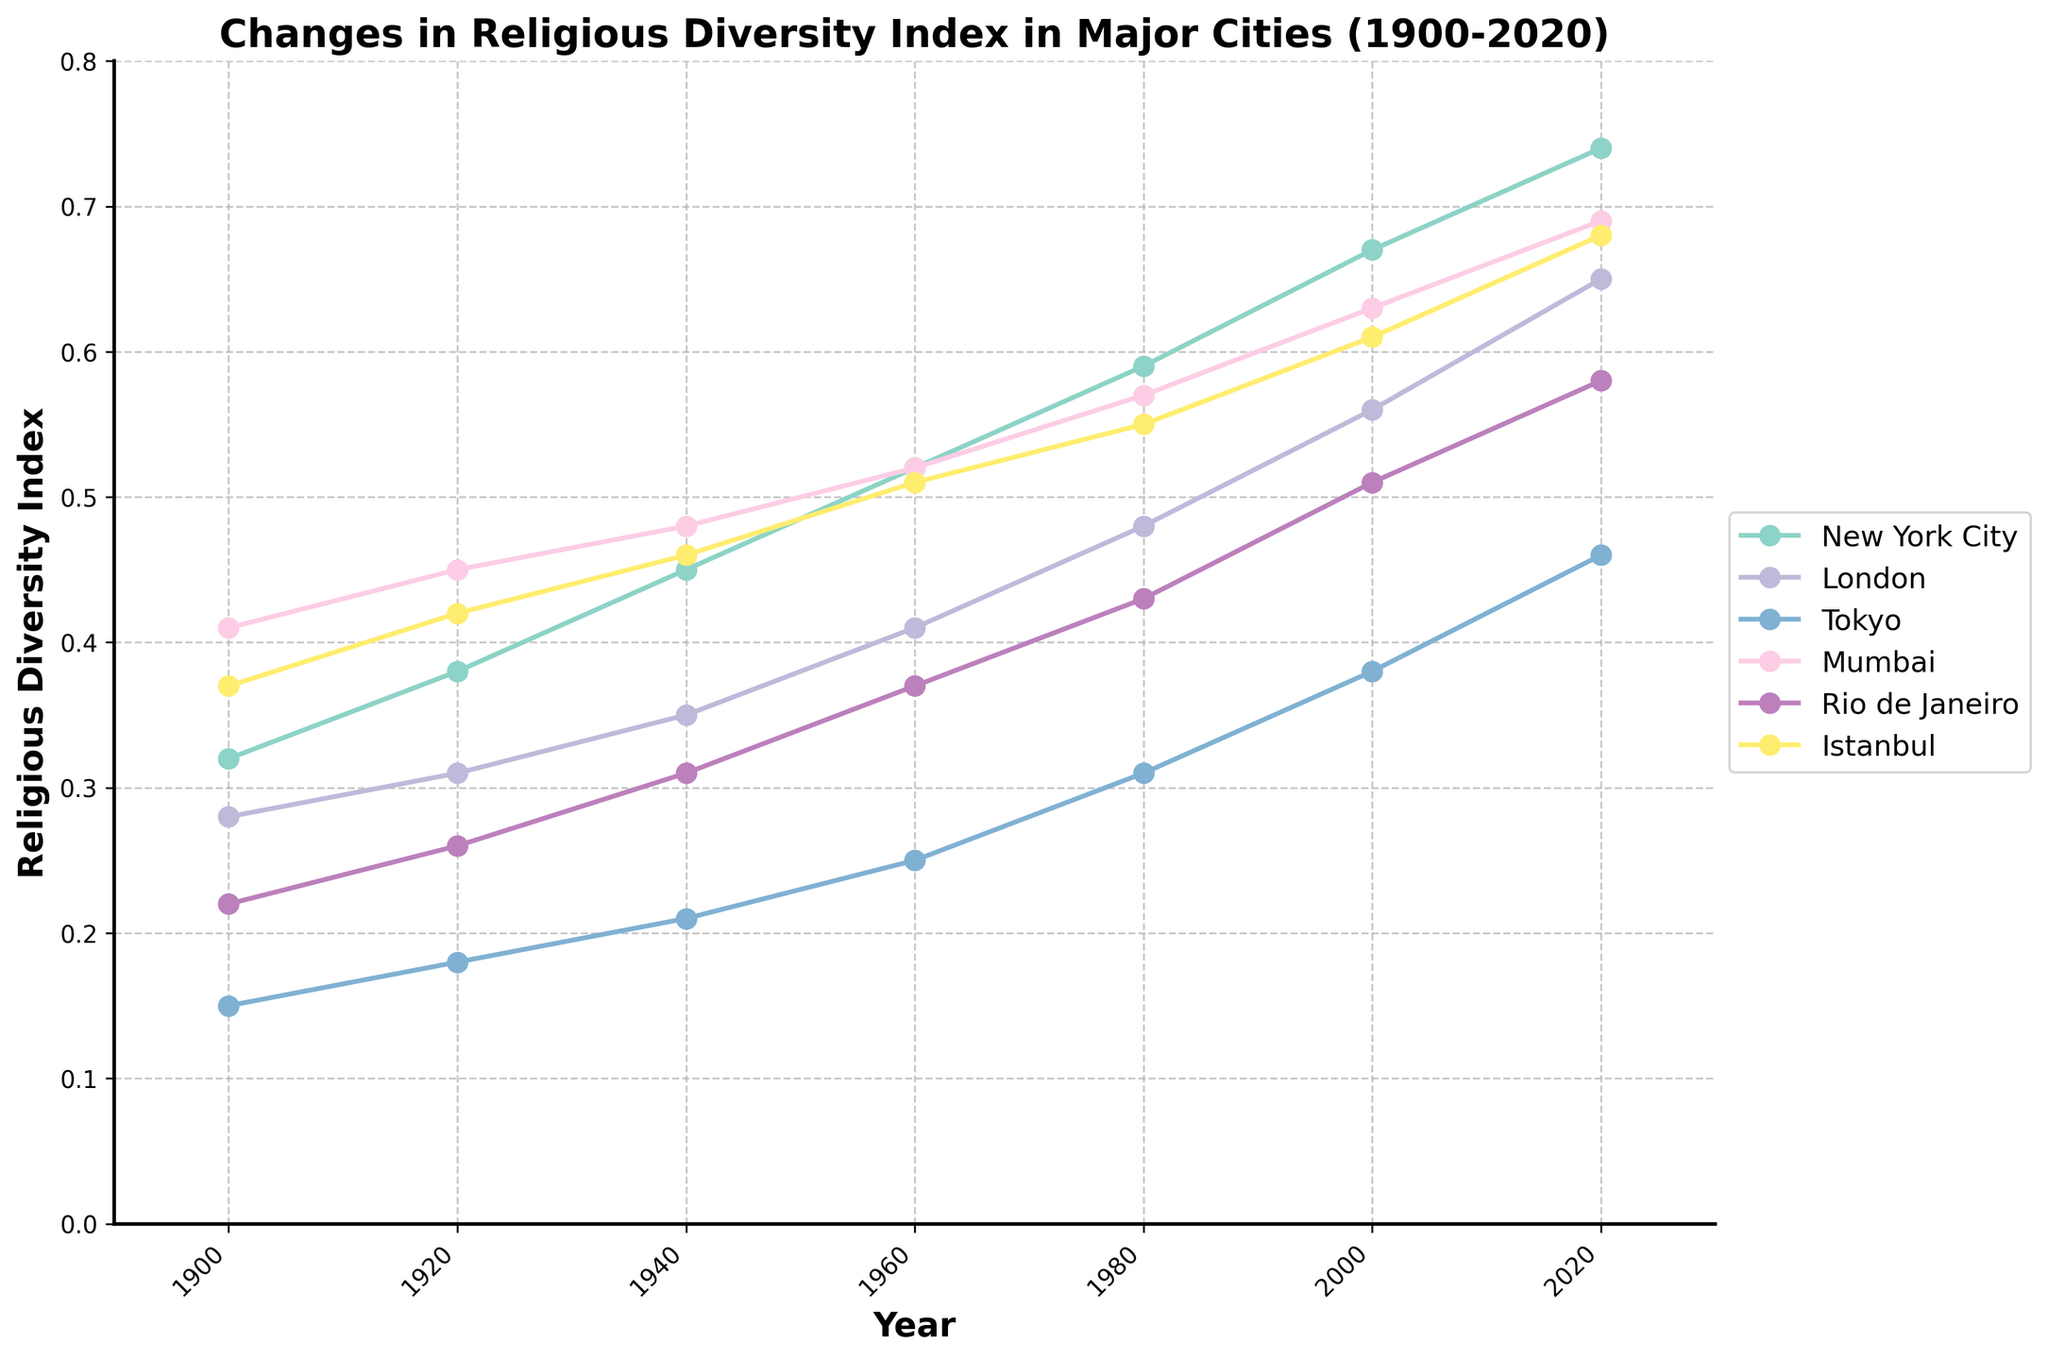Which city had the highest religious diversity index in 2020? The figure shows different lines representing the religious diversity index for various cities from 1900 to 2020. By referencing the endpoints of the lines on the right side of the chart, we can see that New York City had the highest index in 2020.
Answer: New York City How did Tokyo's religious diversity index change from 1900 to 2020? To find the change, look at Tokyo's index in 1900 and compare it with the index in 2020. In 1900, Tokyo had an index of 0.15, while in 2020, it had 0.46. Subtracting these values gives us the change.
Answer: Increased by 0.31 Which city showed the greatest increase in religious diversity index between 1900 and 2020? Determine the index for all cities in 1900 and 2020, then calculate the difference for each city. The city with the largest positive difference is the one with the greatest increase. Comparing all cities, New York City shows the greatest increase (0.74 - 0.32 = 0.42).
Answer: New York City Between 1980 and 2000, which city's religious diversity index grew the fastest? Compare the indices for each city between these years by calculating the difference (2000 - 1980). The city with the highest increase represents the fastest growth. For New York, the increase was 0.67 - 0.59 = 0.08. For London, it was 0.56 - 0.48 = 0.08. For other cities: Tokyo (0.38 - 0.31 = 0.07), Mumbai (0.63 - 0.57 = 0.06), Rio de Janeiro (0.51 - 0.43 = 0.08), and Istanbul (0.61 - 0.55 = 0.06). London and New York have the highest increase of 0.08.
Answer: New York City and London What is the average religious diversity index for Mumbai during the period shown in the figure? To find the average, sum all the indices for Mumbai across all provided years and then divide by the number of years (6). The values are 0.41, 0.45, 0.48, 0.52, 0.57, 0.63, 0.69. Sum is 3.75. Then, 3.75 / 7 = 0.536.
Answer: 0.536 Which city had a higher religious diversity index in 1940, Istanbul or Rio de Janeiro? Refer to the values marked for the year 1940 on the chart for both cities. Istanbul had an index of 0.46, and Rio de Janeiro had an index of 0.31.
Answer: Istanbul What is the difference in religious diversity index between New York City and Tokyo in 2020? Subtract Tokyo’s index value in 2020 from New York City's index value in 2020. For New York City, the index is 0.74, and for Tokyo, it is 0.46. Therefore, the difference is 0.74 - 0.46 = 0.28.
Answer: 0.28 Which city had the steepest rise in religious diversity index during the 20th century (1900-2000)? Calculate the difference for each city between 1900 and 2000 and compare them. For New York City, the difference is 0.67 - 0.32 = 0.35. For London, 0.56 - 0.28 = 0.28. For Tokyo, 0.38 - 0.15 = 0.23. For Mumbai, 0.63 - 0.41 = 0.22. For Rio de Janeiro, 0.51 - 0.22 = 0.29. For Istanbul, 0.61 - 0.37 = 0.24. New York City had the largest rise.
Answer: New York City 